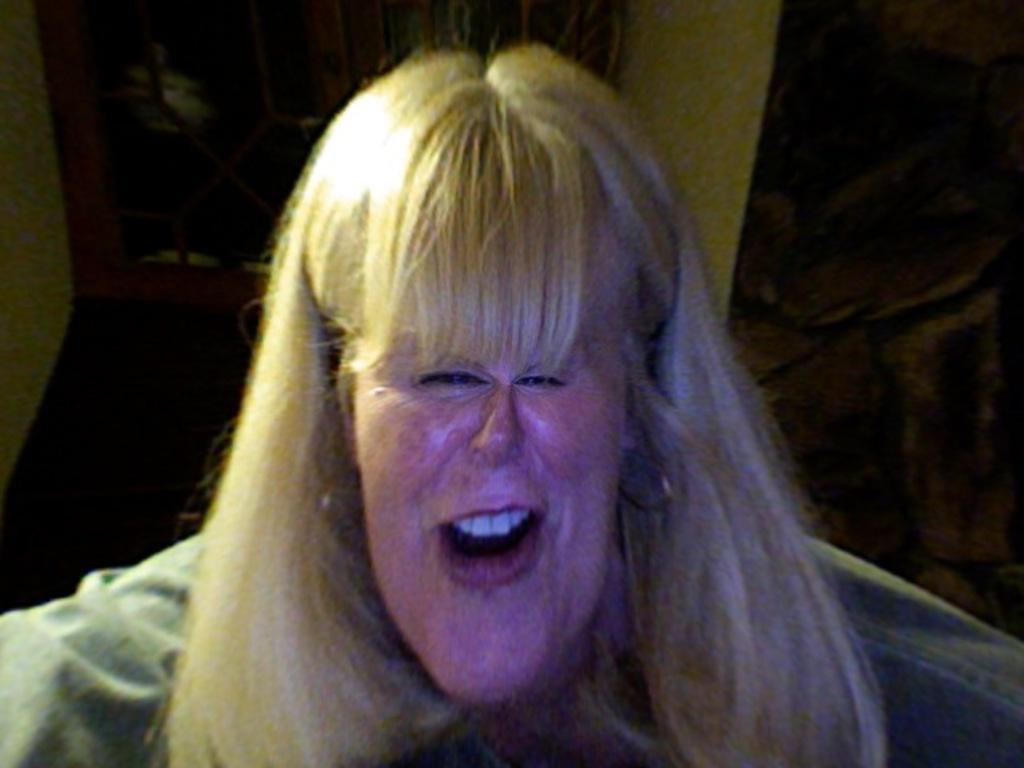In one or two sentences, can you explain what this image depicts? In the picture there is a woman present, behind there may be a wall. 